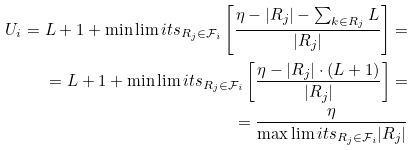Convert formula to latex. <formula><loc_0><loc_0><loc_500><loc_500>U _ { i } = L + 1 + \min \lim i t s _ { R _ { j } \in \mathcal { F } _ { i } } \left [ \frac { \eta - | R _ { j } | - \sum _ { k \in R _ { j } } L } { | R _ { j } | } \right ] = \\ = L + 1 + \min \lim i t s _ { R _ { j } \in \mathcal { F } _ { i } } \left [ \frac { \eta - | R _ { j } | \cdot ( L + 1 ) } { | R _ { j } | } \right ] = \\ = \frac { \eta } { \max \lim i t s _ { R _ { j } \in \mathcal { F } _ { i } } | R _ { j } | }</formula> 